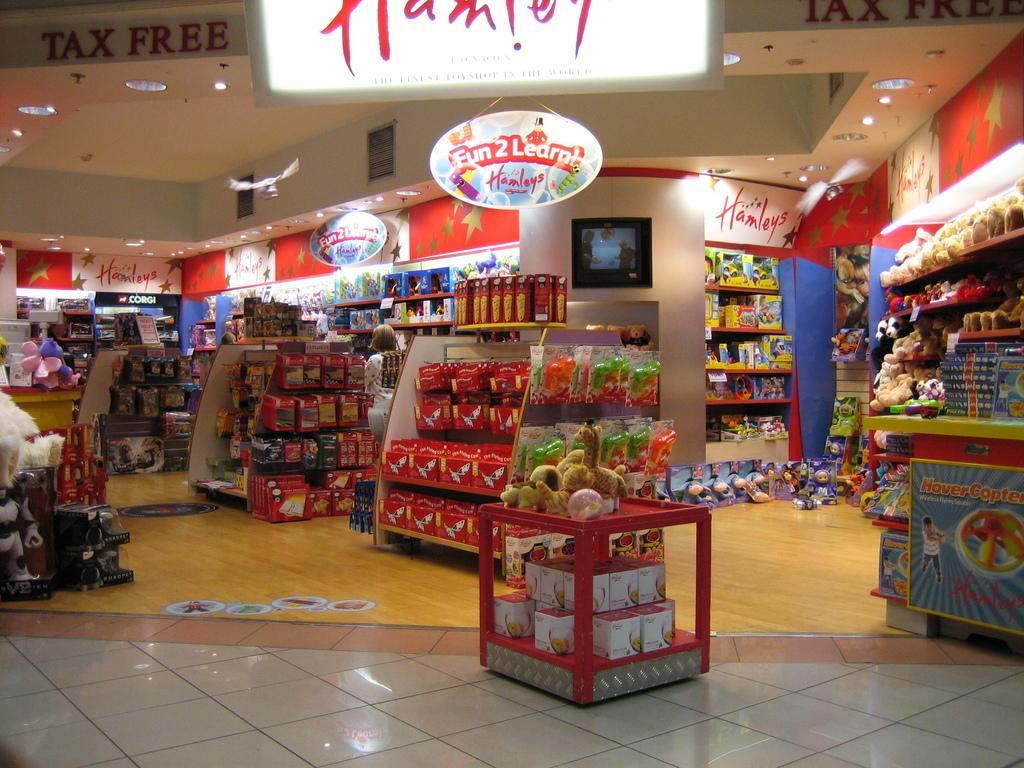<image>
Share a concise interpretation of the image provided. A section in a toy store labeled Fun 2 Learn 